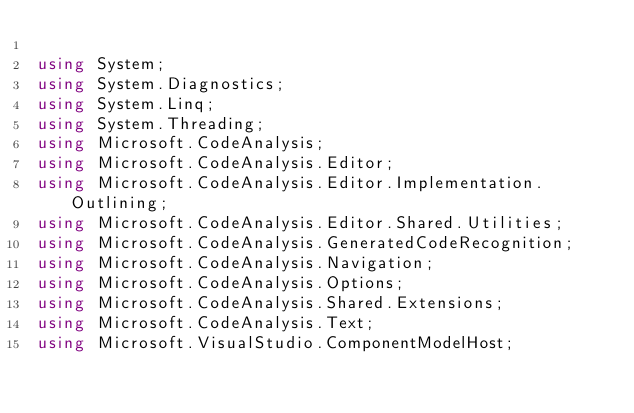<code> <loc_0><loc_0><loc_500><loc_500><_C#_>
using System;
using System.Diagnostics;
using System.Linq;
using System.Threading;
using Microsoft.CodeAnalysis;
using Microsoft.CodeAnalysis.Editor;
using Microsoft.CodeAnalysis.Editor.Implementation.Outlining;
using Microsoft.CodeAnalysis.Editor.Shared.Utilities;
using Microsoft.CodeAnalysis.GeneratedCodeRecognition;
using Microsoft.CodeAnalysis.Navigation;
using Microsoft.CodeAnalysis.Options;
using Microsoft.CodeAnalysis.Shared.Extensions;
using Microsoft.CodeAnalysis.Text;
using Microsoft.VisualStudio.ComponentModelHost;</code> 